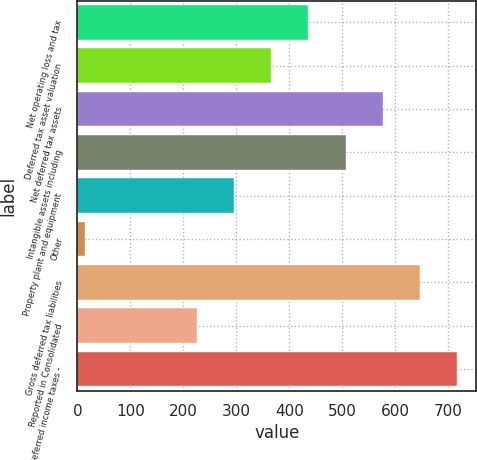Convert chart to OTSL. <chart><loc_0><loc_0><loc_500><loc_500><bar_chart><fcel>Net operating loss and tax<fcel>Deferred tax asset valuation<fcel>Net deferred tax assets<fcel>Intangible assets including<fcel>Property plant and equipment<fcel>Other<fcel>Gross deferred tax liabilities<fcel>Reported in Consolidated<fcel>Deferred income taxes -<nl><fcel>435.8<fcel>365.5<fcel>576.4<fcel>506.1<fcel>295.2<fcel>14<fcel>646.7<fcel>224.9<fcel>717<nl></chart> 